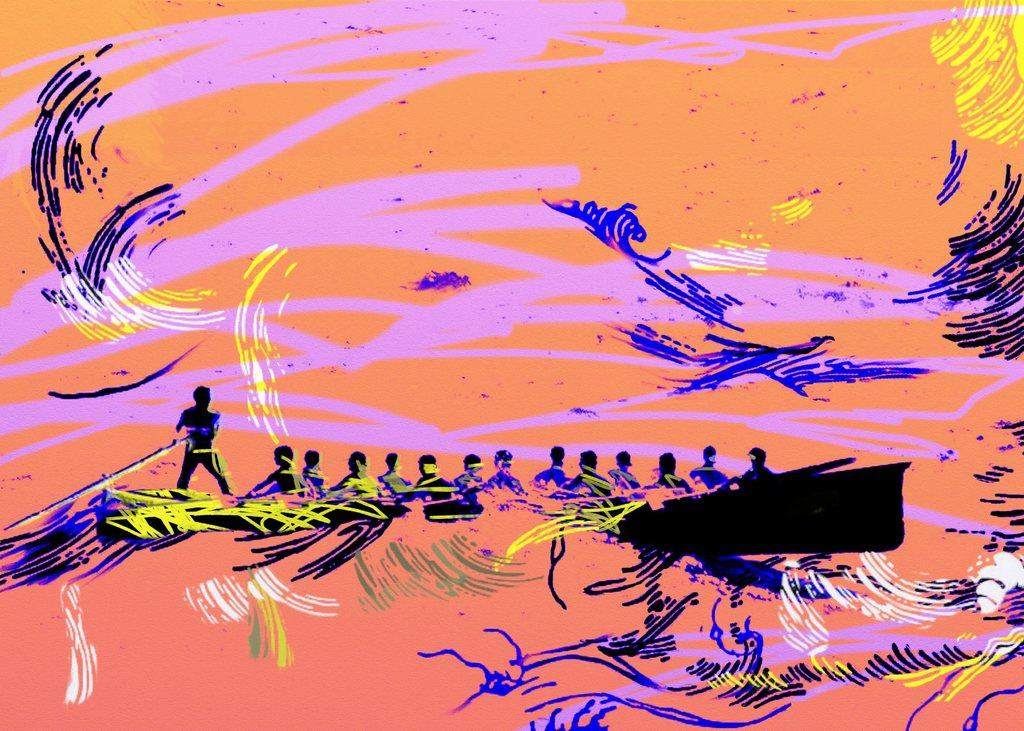What is the main subject of the painting in the image? The painting depicts a boat. What is happening in the painting? There are people sitting in the boat, and there is a man standing and riding the boat with a stick. How many beads are used to create the self-portrait of the man in the painting? There is no self-portrait of the man in the painting, and beads are not mentioned as a medium used in the painting. 